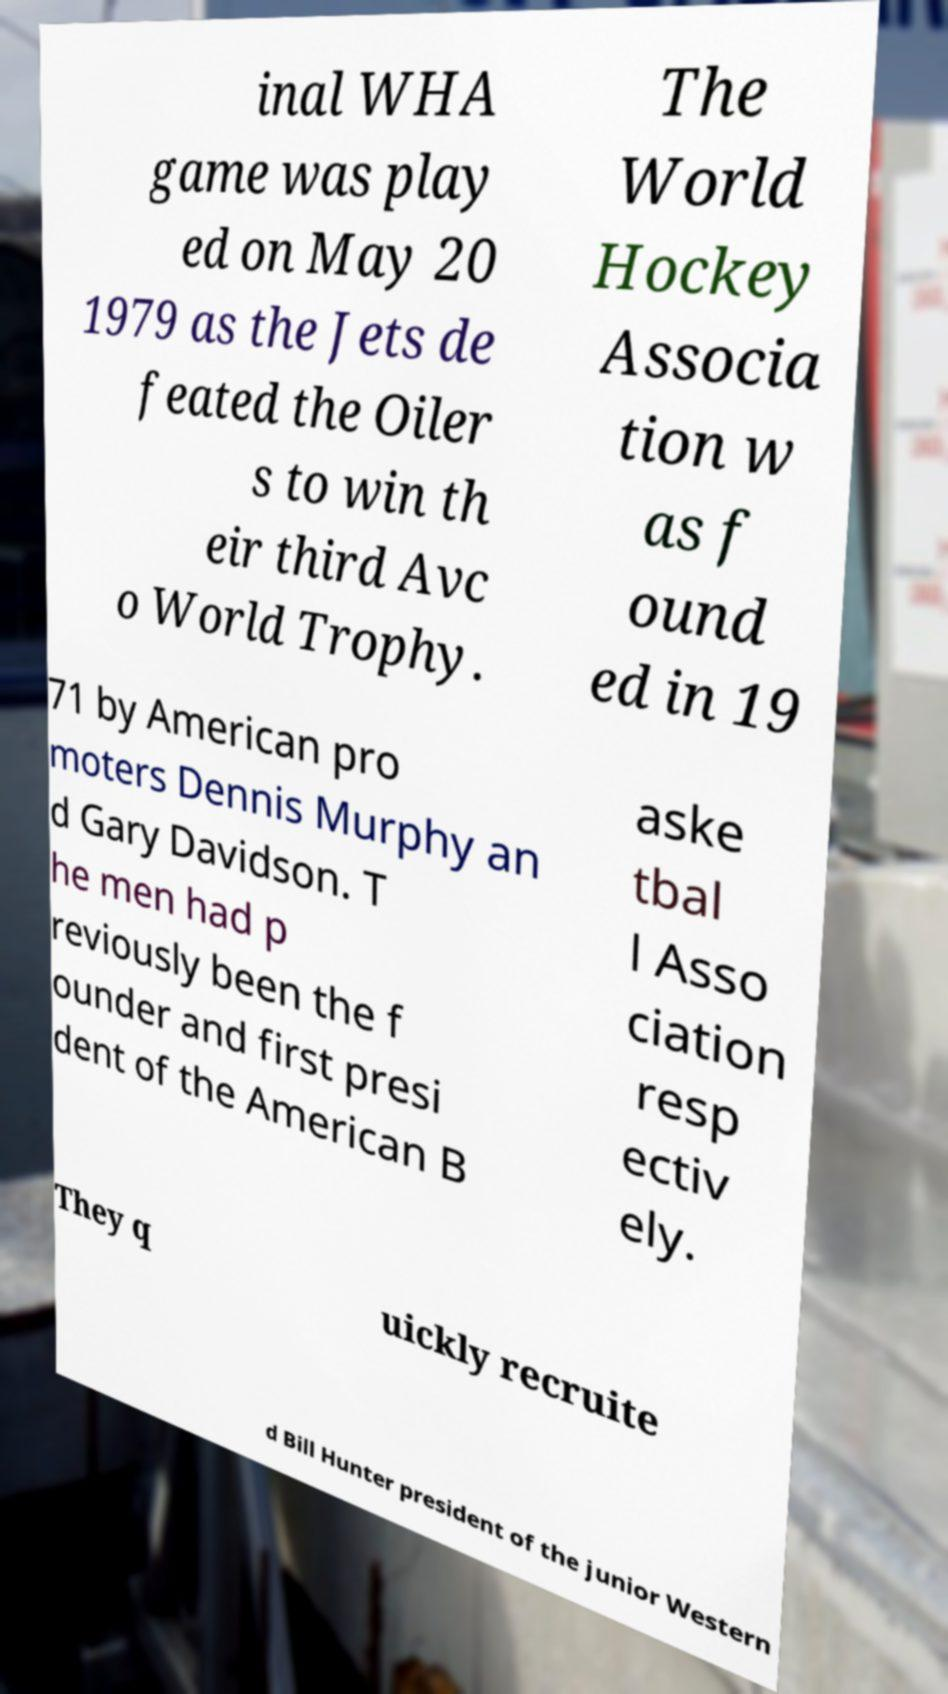Could you assist in decoding the text presented in this image and type it out clearly? inal WHA game was play ed on May 20 1979 as the Jets de feated the Oiler s to win th eir third Avc o World Trophy. The World Hockey Associa tion w as f ound ed in 19 71 by American pro moters Dennis Murphy an d Gary Davidson. T he men had p reviously been the f ounder and first presi dent of the American B aske tbal l Asso ciation resp ectiv ely. They q uickly recruite d Bill Hunter president of the junior Western 